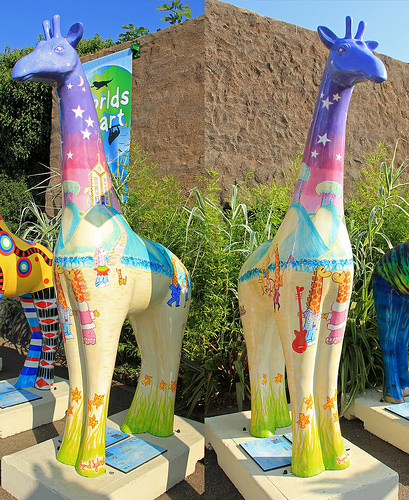<image>
Is there a giraffe in front of the grass? Yes. The giraffe is positioned in front of the grass, appearing closer to the camera viewpoint. Is the wall in front of the poster? No. The wall is not in front of the poster. The spatial positioning shows a different relationship between these objects. 